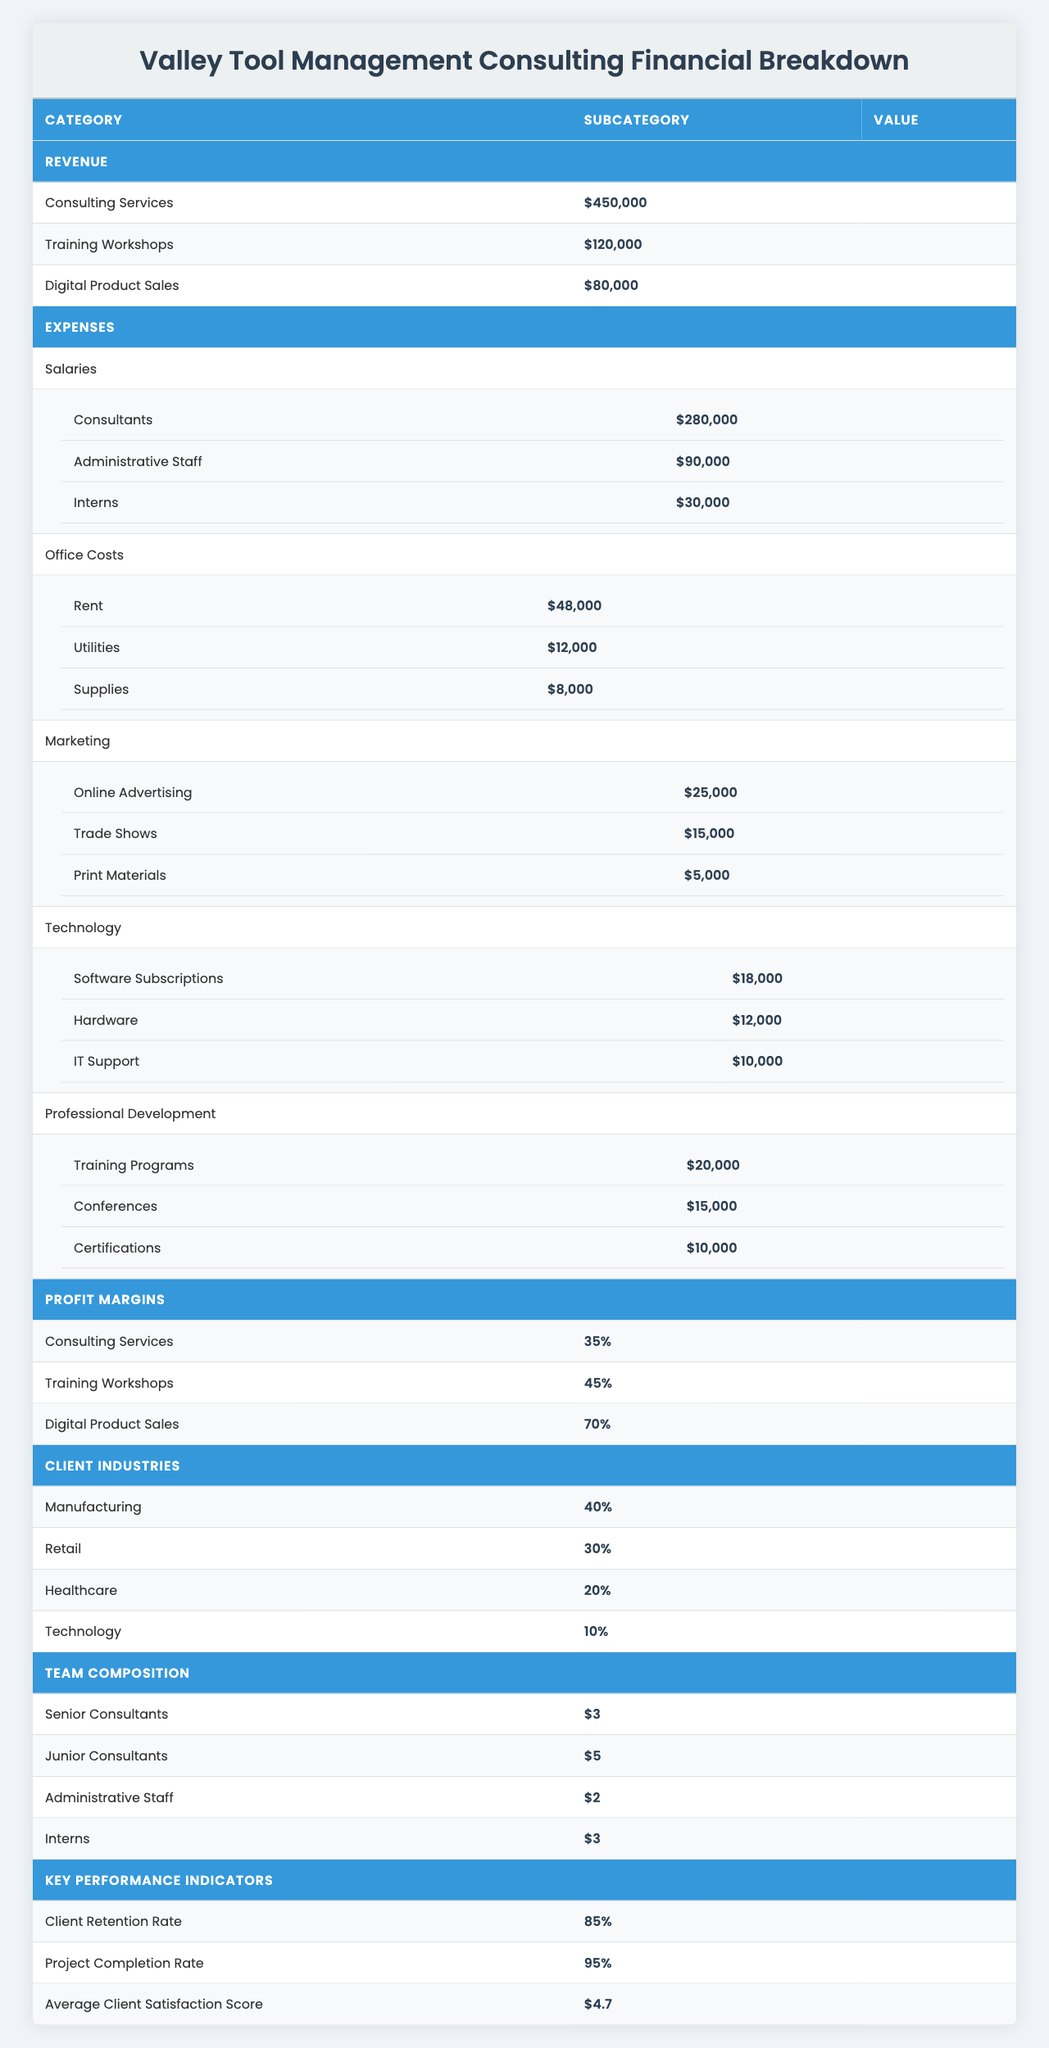What is the total revenue of Valley Tool Management Consulting? The total revenue is the sum of all revenue sources: Consulting Services ($450,000) + Training Workshops ($120,000) + Digital Product Sales ($80,000) = $650,000.
Answer: $650,000 What is the expense for Salaries? The total expenses for Salaries is the sum of all salary categories: Consultants ($280,000) + Administrative Staff ($90,000) + Interns ($30,000) = $400,000.
Answer: $400,000 What percentage of clients come from the Manufacturing industry? According to the table, 40% of clients come from the Manufacturing industry.
Answer: 40% Is the average client satisfaction score above 4.5? The average client satisfaction score listed is 4.7, which is greater than 4.5.
Answer: Yes What is the total cost for Office Costs? The total cost for Office Costs is calculated as: Rent ($48,000) + Utilities ($12,000) + Supplies ($8,000) = $68,000.
Answer: $68,000 What is the profit margin for the Digital Product Sales? The profit margin stated for Digital Product Sales is 70%.
Answer: 70% How much do Marketing expenses total? The total Marketing expenses can be computed by adding: Online Advertising ($25,000) + Trade Shows ($15,000) + Print Materials ($5,000) = $45,000.
Answer: $45,000 How many Junior Consultants does Valley Tool have? The table specifies that there are 5 Junior Consultants in the team composition.
Answer: 5 If you were to calculate the total expenses, what would it be? Total expenses are found by summing all the expenses categories: Salaries ($400,000) + Office Costs ($68,000) + Marketing ($45,000) + Technology ($40,000) + Professional Development ($35,000) = $628,000.
Answer: $628,000 What is the Client Retention Rate? The Client Retention Rate shown in the table is 85%.
Answer: 85% 